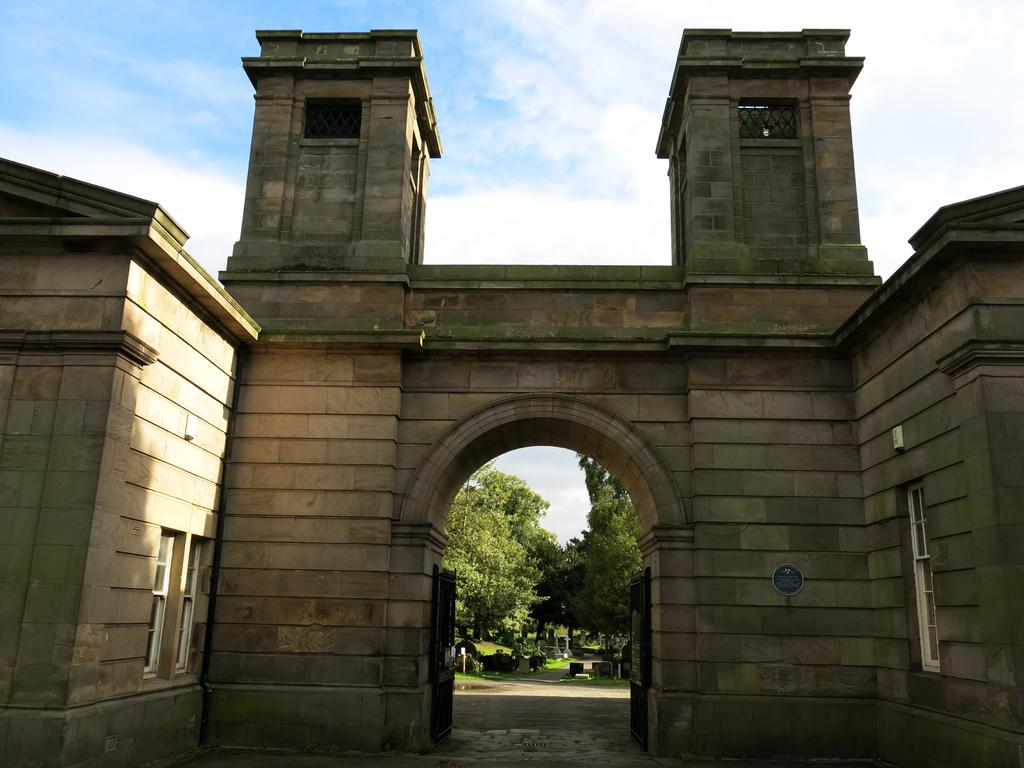What is a prominent feature in the image? There is a wall in the image. Are there any openings in the wall? Yes, there are windows in the image. What can be seen in the background of the image? There are trees, grass, and the sky visible in the background of the image. What is the condition of the sky in the image? Clouds are present in the sky. What type of scarf is hanging from the tree in the image? There is no scarf present in the image; it only features trees, grass, and the sky in the background. 